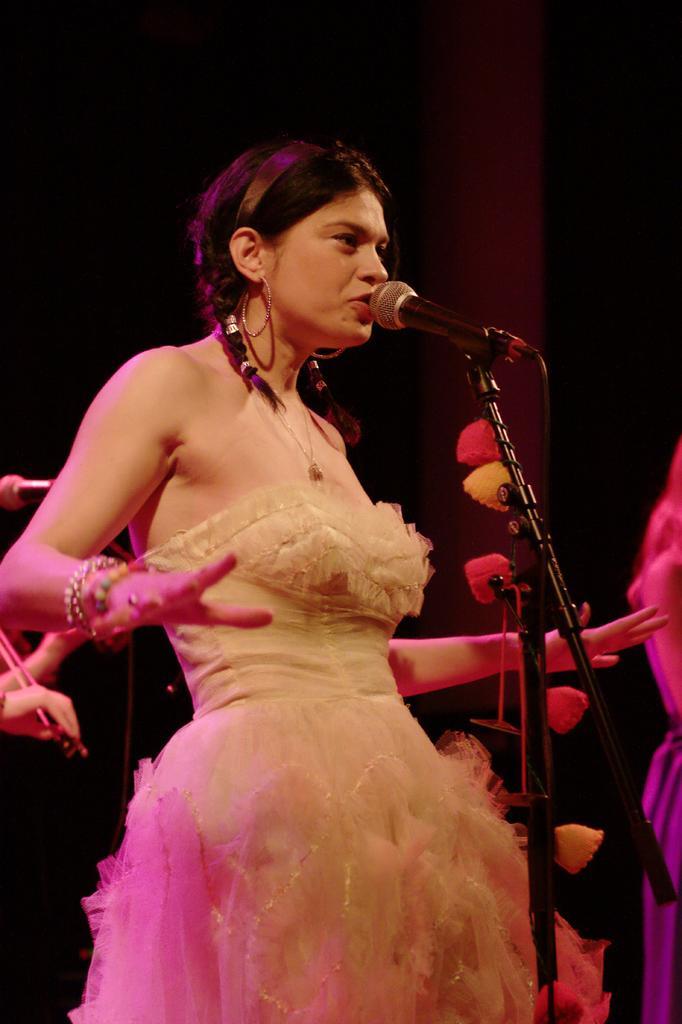How would you summarize this image in a sentence or two? In this image there is a woman standing. In front of her there is a microphone to its stand. Behind her there are hands of a person and a microphone. The background is dark. 